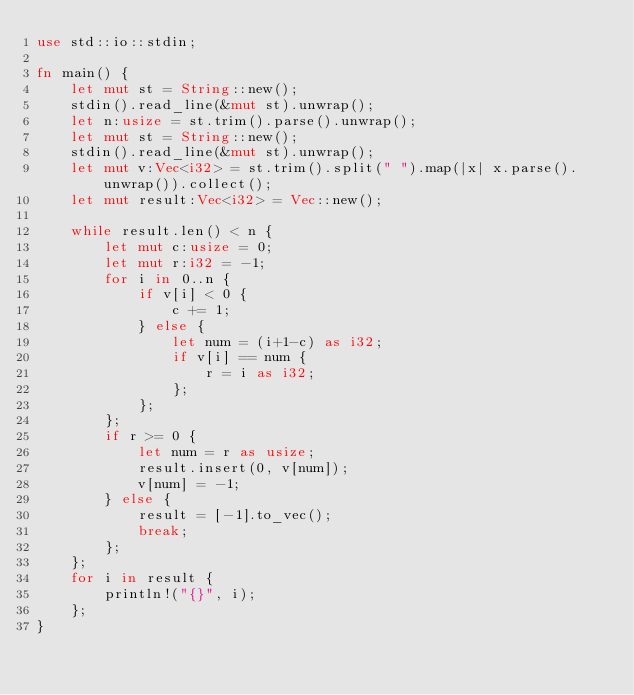<code> <loc_0><loc_0><loc_500><loc_500><_Rust_>use std::io::stdin;

fn main() {
    let mut st = String::new();
    stdin().read_line(&mut st).unwrap();
    let n:usize = st.trim().parse().unwrap();
    let mut st = String::new();
    stdin().read_line(&mut st).unwrap();
    let mut v:Vec<i32> = st.trim().split(" ").map(|x| x.parse().unwrap()).collect();
    let mut result:Vec<i32> = Vec::new();

    while result.len() < n {
        let mut c:usize = 0;
        let mut r:i32 = -1;
        for i in 0..n {
            if v[i] < 0 {
                c += 1;
            } else {
            	let num = (i+1-c) as i32;
                if v[i] == num {
                    r = i as i32;
                };
            };
        };
        if r >= 0 {
        	let num = r as usize;
            result.insert(0, v[num]);
            v[num] = -1;
        } else {
            result = [-1].to_vec();
            break;
        };
    };
    for i in result {
        println!("{}", i);
    };
}</code> 